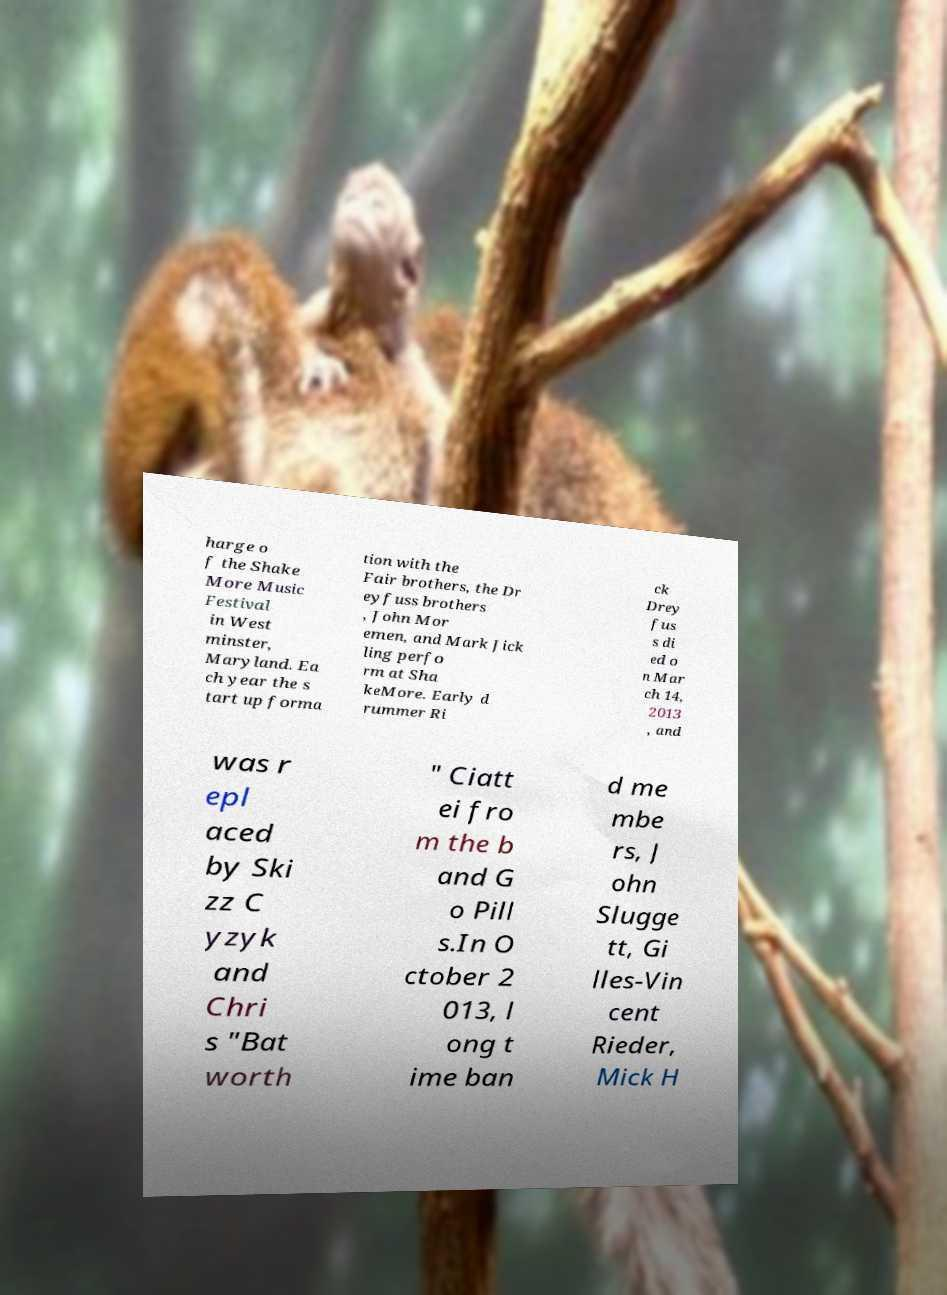Can you read and provide the text displayed in the image?This photo seems to have some interesting text. Can you extract and type it out for me? harge o f the Shake More Music Festival in West minster, Maryland. Ea ch year the s tart up forma tion with the Fair brothers, the Dr eyfuss brothers , John Mor emen, and Mark Jick ling perfo rm at Sha keMore. Early d rummer Ri ck Drey fus s di ed o n Mar ch 14, 2013 , and was r epl aced by Ski zz C yzyk and Chri s "Bat worth " Ciatt ei fro m the b and G o Pill s.In O ctober 2 013, l ong t ime ban d me mbe rs, J ohn Slugge tt, Gi lles-Vin cent Rieder, Mick H 